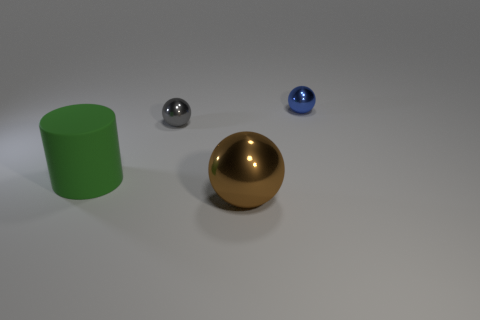Can you describe the background of this scene? The background appears to be a neutral, off-white color, providing a non-distracting environment that highlights the objects in the foreground. 